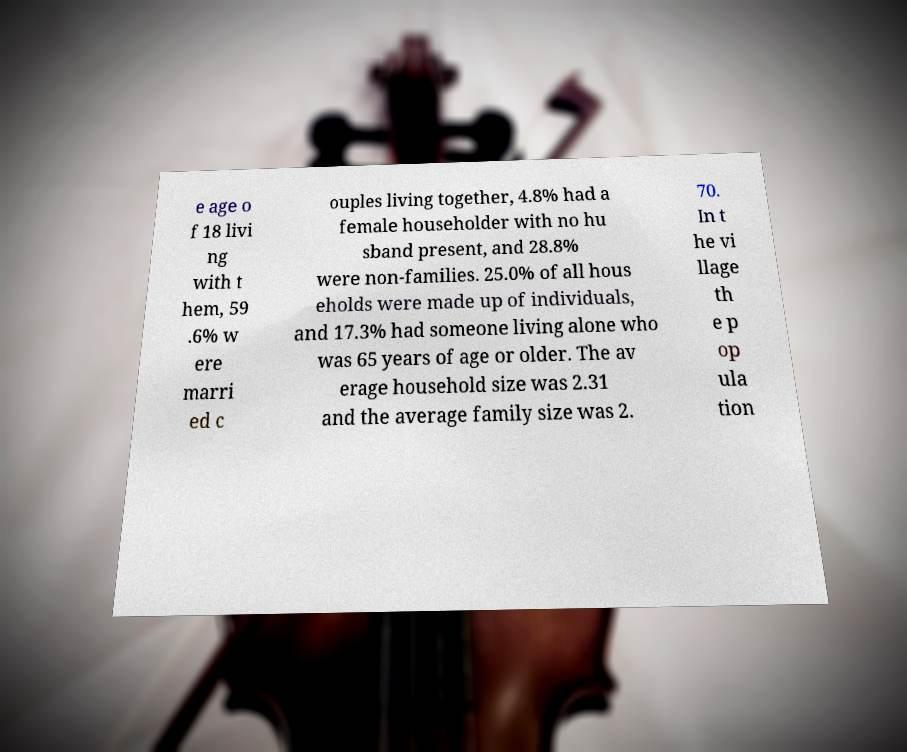Please identify and transcribe the text found in this image. e age o f 18 livi ng with t hem, 59 .6% w ere marri ed c ouples living together, 4.8% had a female householder with no hu sband present, and 28.8% were non-families. 25.0% of all hous eholds were made up of individuals, and 17.3% had someone living alone who was 65 years of age or older. The av erage household size was 2.31 and the average family size was 2. 70. In t he vi llage th e p op ula tion 